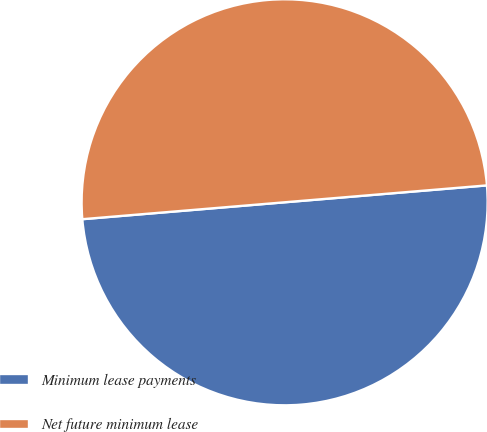<chart> <loc_0><loc_0><loc_500><loc_500><pie_chart><fcel>Minimum lease payments<fcel>Net future minimum lease<nl><fcel>50.0%<fcel>50.0%<nl></chart> 